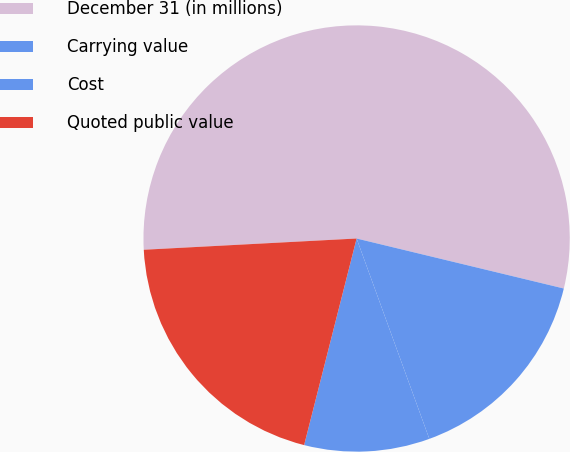Convert chart. <chart><loc_0><loc_0><loc_500><loc_500><pie_chart><fcel>December 31 (in millions)<fcel>Carrying value<fcel>Cost<fcel>Quoted public value<nl><fcel>54.61%<fcel>15.69%<fcel>9.5%<fcel>20.2%<nl></chart> 